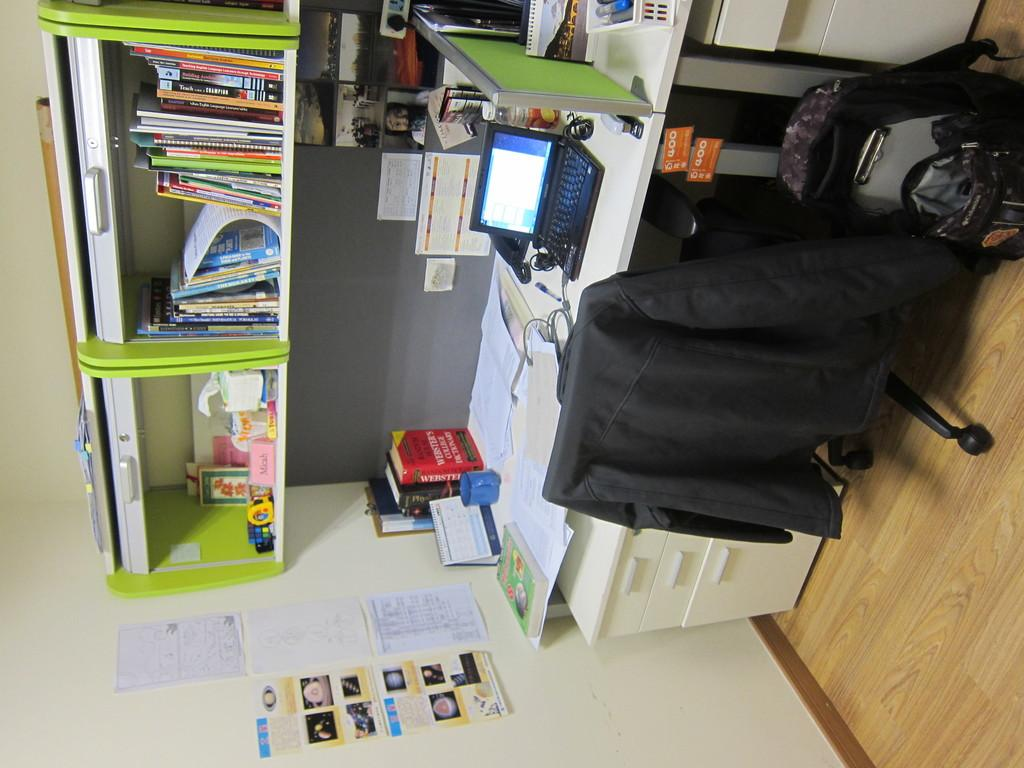<image>
Give a short and clear explanation of the subsequent image. A red book has the word Winter's on it in white lettering. 